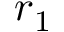Convert formula to latex. <formula><loc_0><loc_0><loc_500><loc_500>r _ { 1 }</formula> 